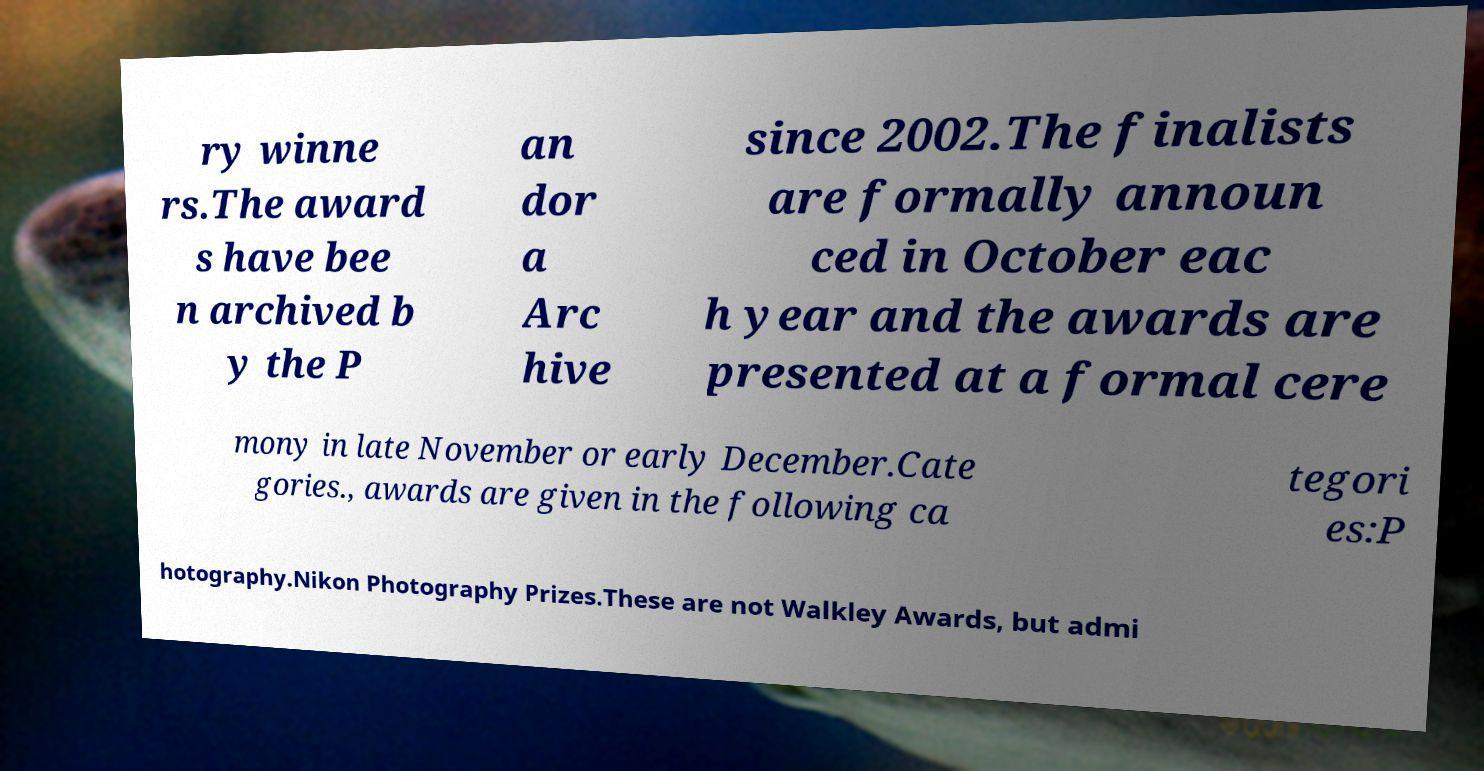Please identify and transcribe the text found in this image. ry winne rs.The award s have bee n archived b y the P an dor a Arc hive since 2002.The finalists are formally announ ced in October eac h year and the awards are presented at a formal cere mony in late November or early December.Cate gories., awards are given in the following ca tegori es:P hotography.Nikon Photography Prizes.These are not Walkley Awards, but admi 